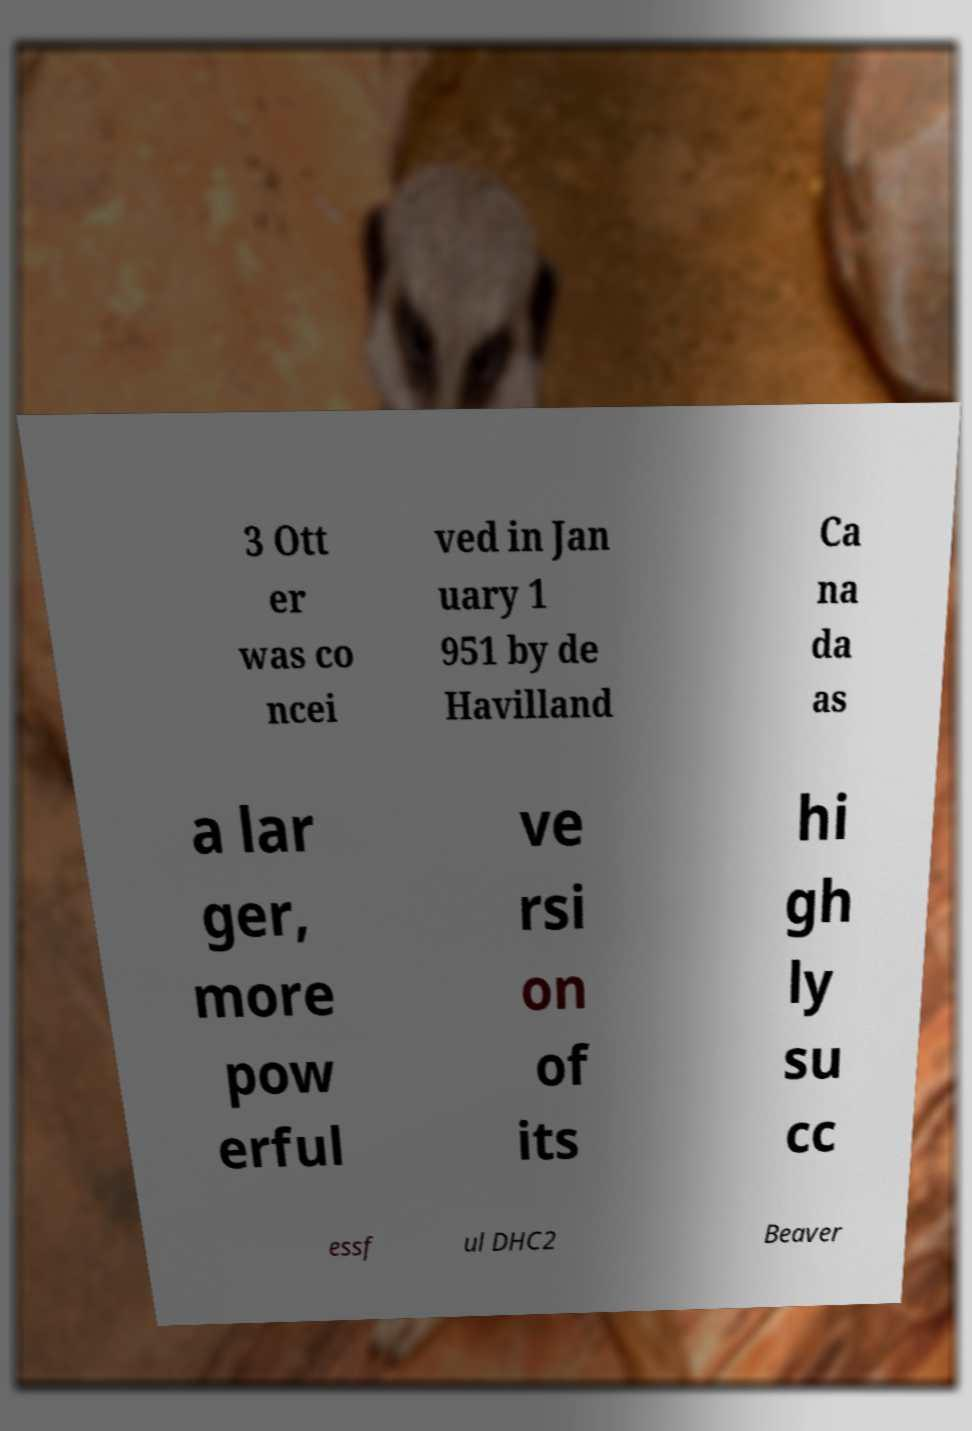Could you assist in decoding the text presented in this image and type it out clearly? 3 Ott er was co ncei ved in Jan uary 1 951 by de Havilland Ca na da as a lar ger, more pow erful ve rsi on of its hi gh ly su cc essf ul DHC2 Beaver 